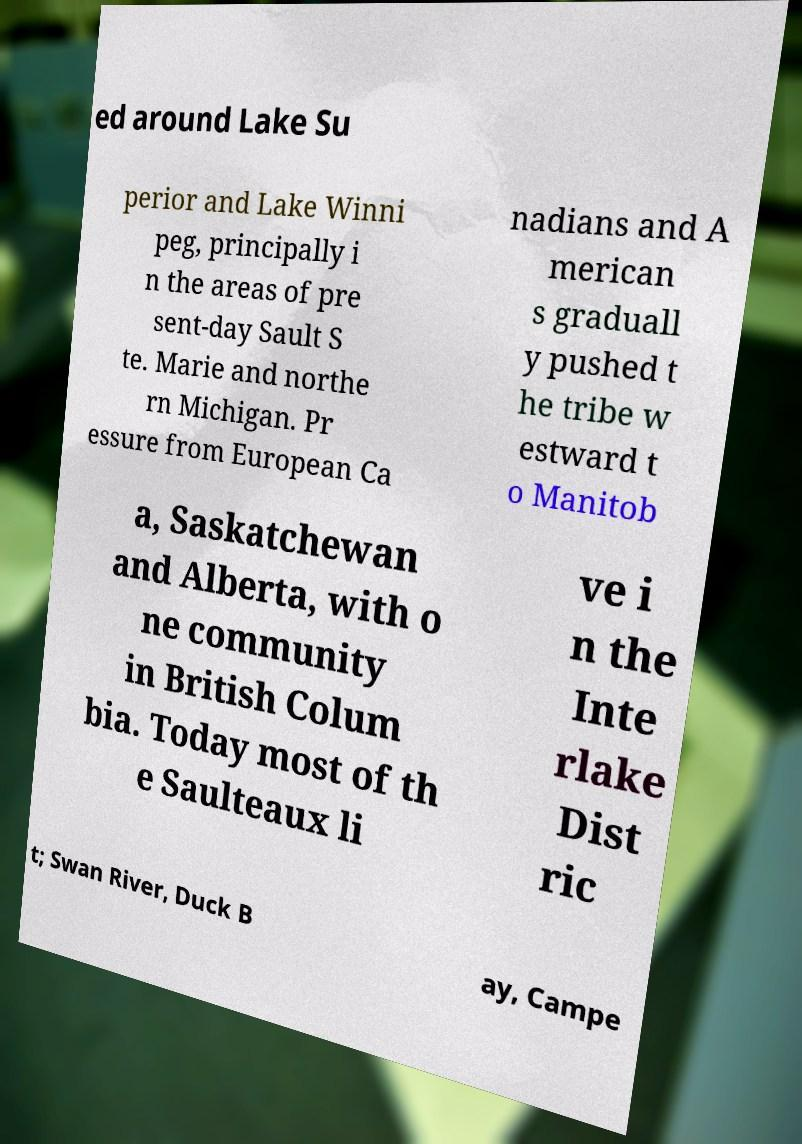Please read and relay the text visible in this image. What does it say? ed around Lake Su perior and Lake Winni peg, principally i n the areas of pre sent-day Sault S te. Marie and northe rn Michigan. Pr essure from European Ca nadians and A merican s graduall y pushed t he tribe w estward t o Manitob a, Saskatchewan and Alberta, with o ne community in British Colum bia. Today most of th e Saulteaux li ve i n the Inte rlake Dist ric t; Swan River, Duck B ay, Campe 